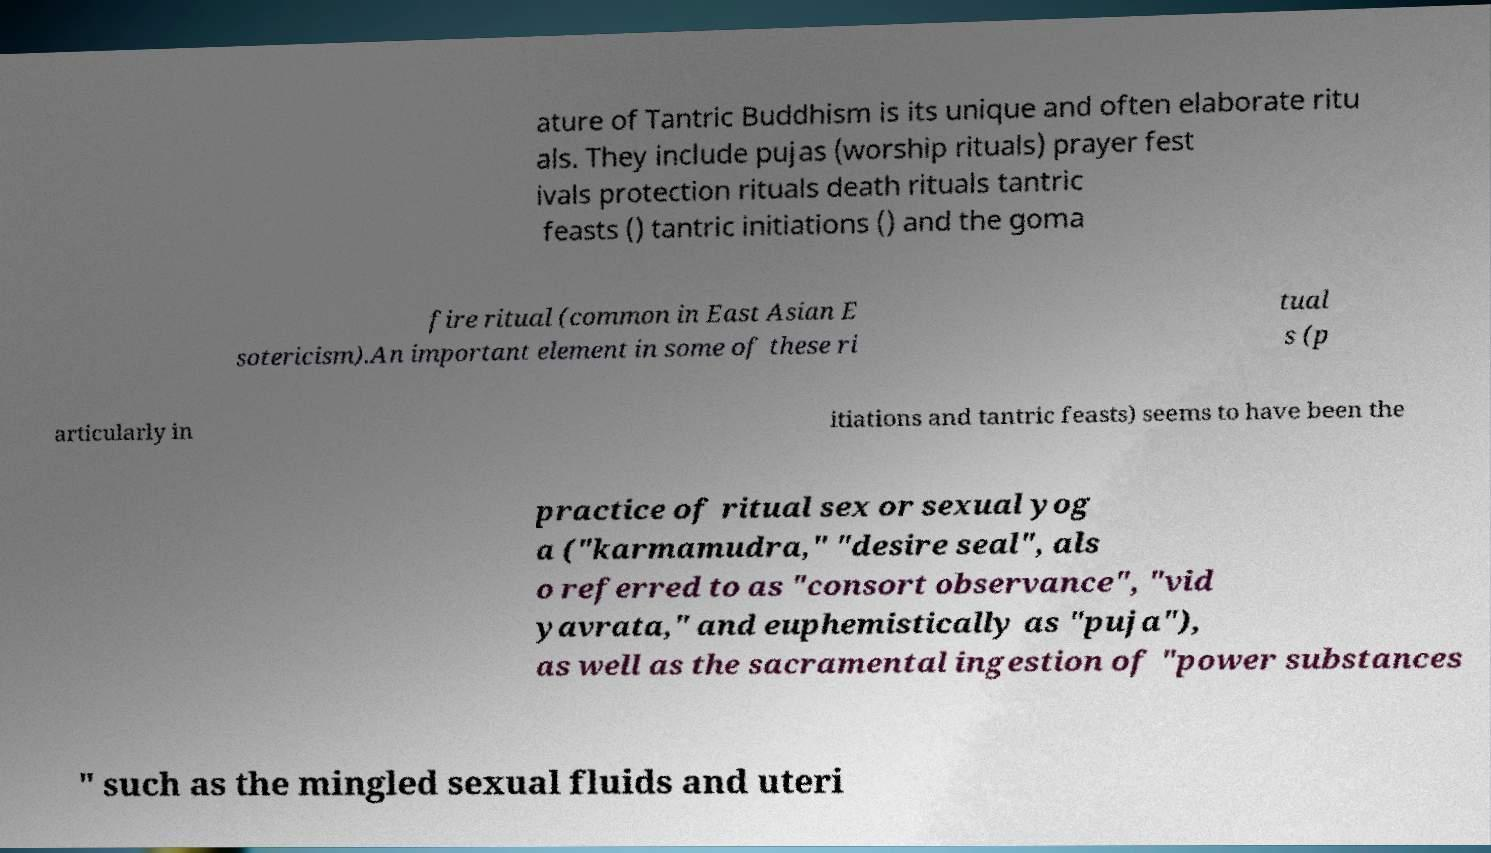There's text embedded in this image that I need extracted. Can you transcribe it verbatim? ature of Tantric Buddhism is its unique and often elaborate ritu als. They include pujas (worship rituals) prayer fest ivals protection rituals death rituals tantric feasts () tantric initiations () and the goma fire ritual (common in East Asian E sotericism).An important element in some of these ri tual s (p articularly in itiations and tantric feasts) seems to have been the practice of ritual sex or sexual yog a ("karmamudra," "desire seal", als o referred to as "consort observance", "vid yavrata," and euphemistically as "puja"), as well as the sacramental ingestion of "power substances " such as the mingled sexual fluids and uteri 